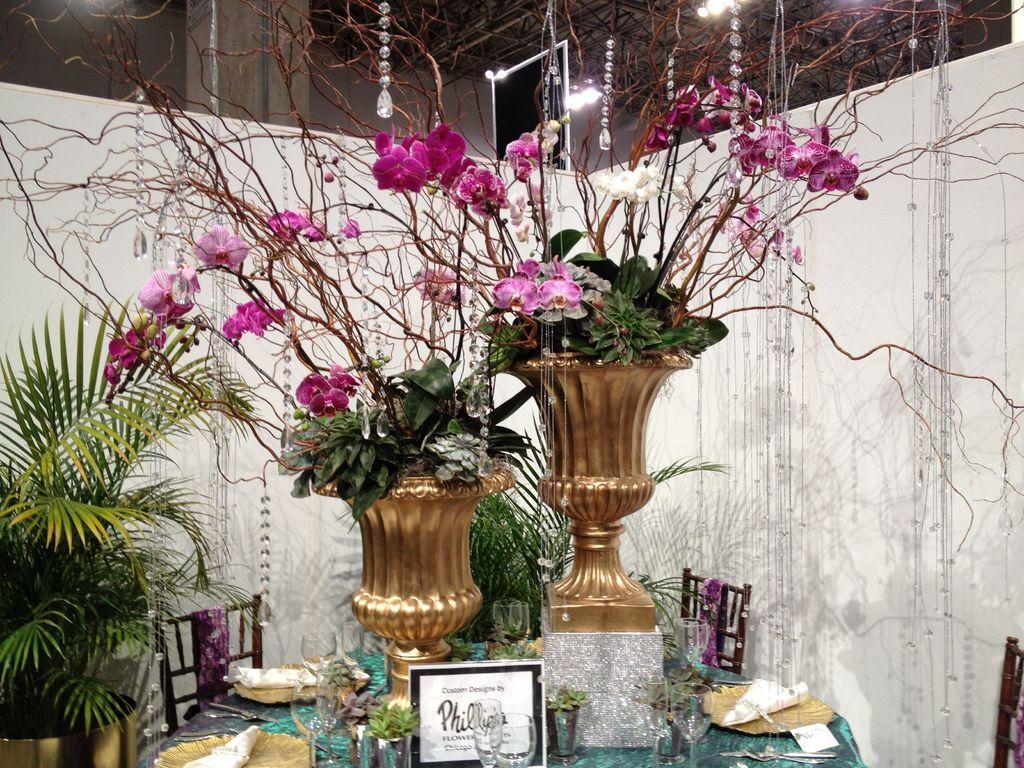Can you describe this image briefly? In the middle of the image there is table, On the table there are some glasses and there are some flower pots. Bottom left side of the image there is a plant. At the top of the image there is a roof and lights. 